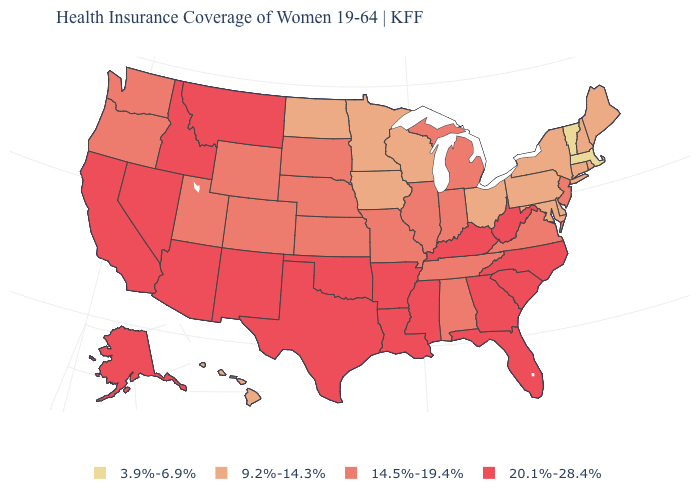What is the highest value in states that border Nebraska?
Write a very short answer. 14.5%-19.4%. What is the value of New York?
Quick response, please. 9.2%-14.3%. Which states have the lowest value in the USA?
Answer briefly. Massachusetts, Vermont. Does North Carolina have the same value as Louisiana?
Write a very short answer. Yes. Name the states that have a value in the range 3.9%-6.9%?
Concise answer only. Massachusetts, Vermont. Among the states that border Iowa , does Illinois have the lowest value?
Concise answer only. No. Among the states that border Pennsylvania , does New York have the highest value?
Concise answer only. No. Name the states that have a value in the range 3.9%-6.9%?
Keep it brief. Massachusetts, Vermont. What is the highest value in states that border Minnesota?
Give a very brief answer. 14.5%-19.4%. What is the value of Virginia?
Answer briefly. 14.5%-19.4%. How many symbols are there in the legend?
Concise answer only. 4. Does Arizona have the lowest value in the USA?
Concise answer only. No. Name the states that have a value in the range 20.1%-28.4%?
Concise answer only. Alaska, Arizona, Arkansas, California, Florida, Georgia, Idaho, Kentucky, Louisiana, Mississippi, Montana, Nevada, New Mexico, North Carolina, Oklahoma, South Carolina, Texas, West Virginia. Which states have the lowest value in the USA?
Quick response, please. Massachusetts, Vermont. Name the states that have a value in the range 3.9%-6.9%?
Short answer required. Massachusetts, Vermont. 